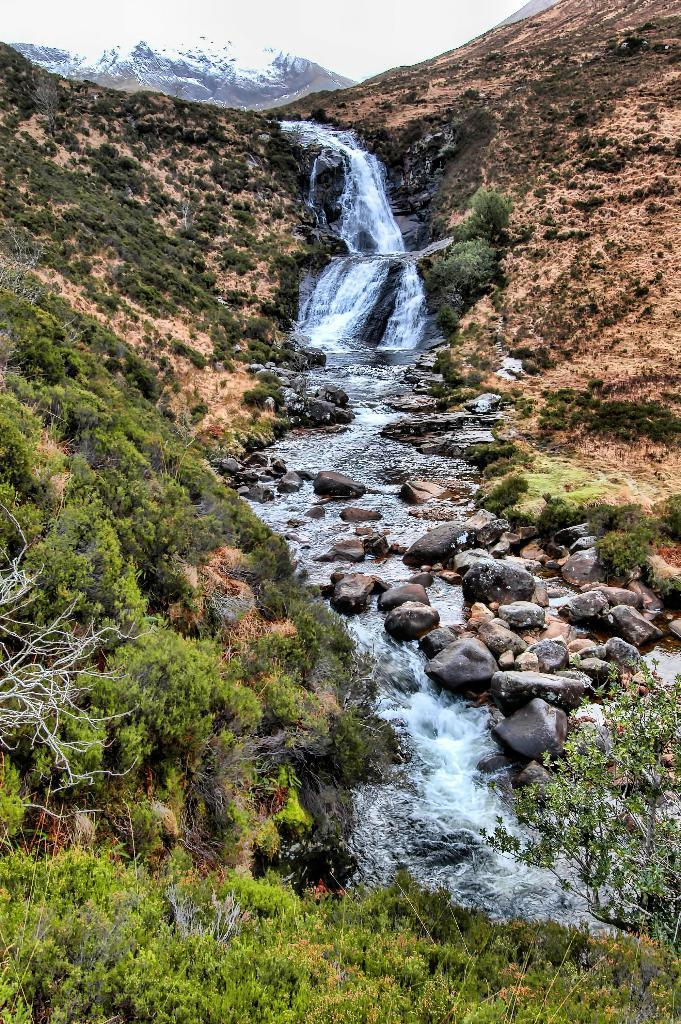What natural feature is the main subject of the image? There is a waterfall in the image. What else can be seen in the image besides the waterfall? There are rocks, grass and plants on the ground, hills, and the sky visible in the image. How would you describe the terrain in the image? The ground is covered with grass and plants, and there are rocks and hills visible. Can you see a plane flying over the waterfall in the image? No, there is no plane visible in the image. Where is the bucket located in the image? There is no bucket present in the image. 